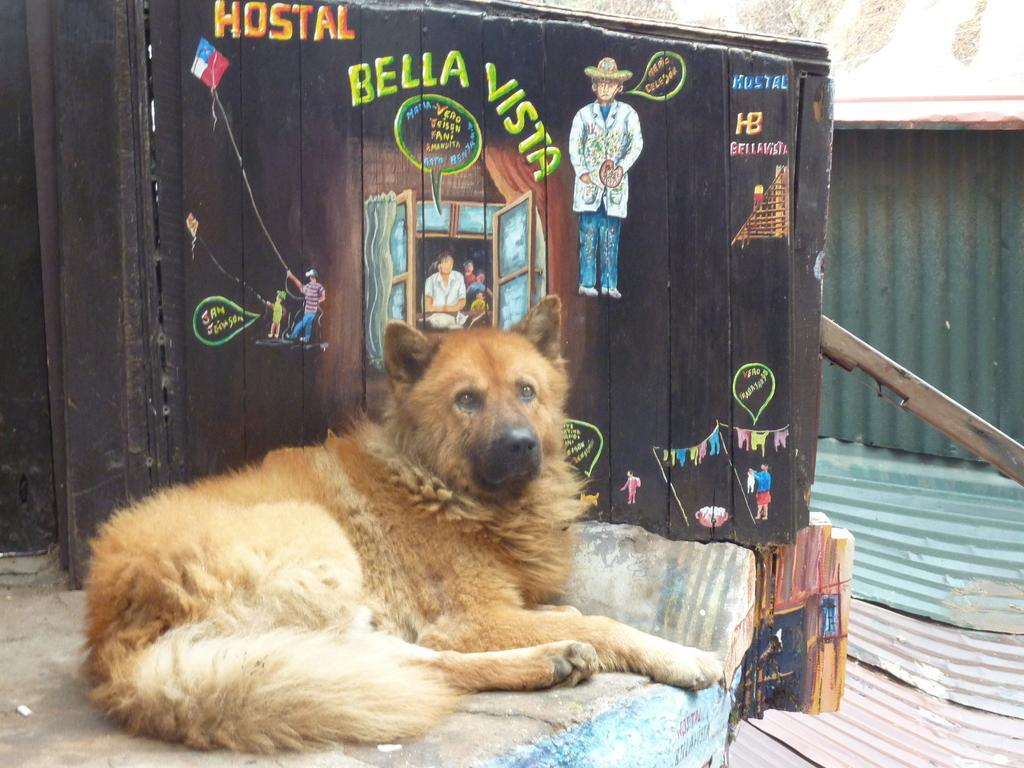What animal is sitting in the image? There is a dog sitting in the image. What can be seen through the window in the image? There is no information about what can be seen through the window in the image. What is the person in the image doing? The person is standing in the image. What type of vegetation is visible in the image? There are trees in the image. What type of structure is present in the image? There is a shed in the image. How many clocks are hanging on the wall in the image? There is no information about any clocks in the image. What are the sisters doing in the image? There is no information about any sisters in the image. 